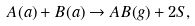Convert formula to latex. <formula><loc_0><loc_0><loc_500><loc_500>A ( a ) + B ( a ) \rightarrow A B ( g ) + 2 S ,</formula> 